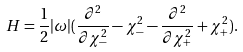<formula> <loc_0><loc_0><loc_500><loc_500>H = \frac { 1 } { 2 } | \omega | ( \frac { \partial ^ { 2 } } { \partial \chi _ { - } ^ { 2 } } - \chi _ { - } ^ { 2 } - \frac { \partial ^ { 2 } } { \partial \chi _ { + } ^ { 2 } } + \chi _ { + } ^ { 2 } ) .</formula> 